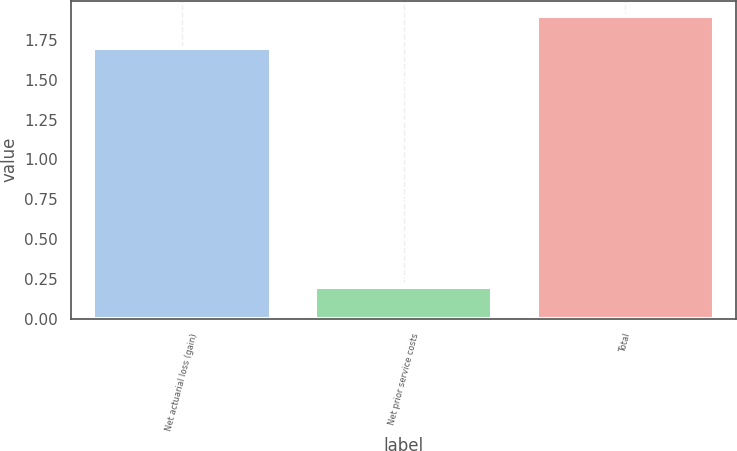<chart> <loc_0><loc_0><loc_500><loc_500><bar_chart><fcel>Net actuarial loss (gain)<fcel>Net prior service costs<fcel>Total<nl><fcel>1.7<fcel>0.2<fcel>1.9<nl></chart> 